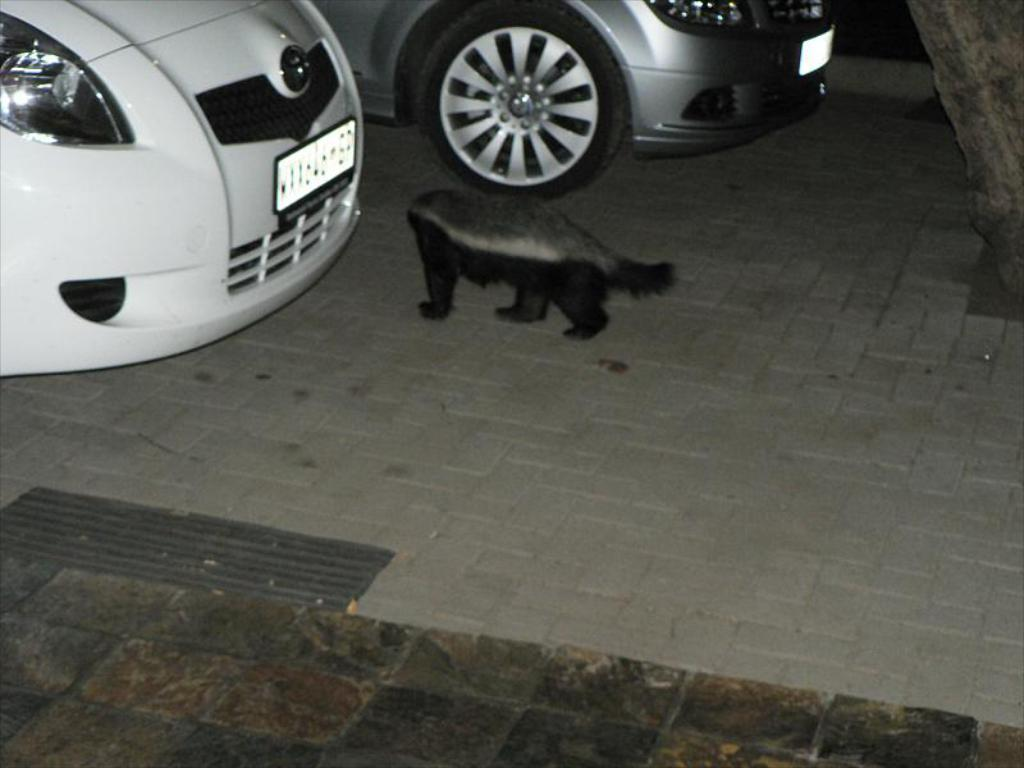What can be seen parked in the image? There are cars parked in the image. What else is present on the floor in the image? There is a dog puppy on the floor in the image. What is the color of the dog puppy? The dog puppy is black in color. What type of gate can be seen in the image? There is no gate present in the image; it only features cars parked and a dog puppy on the floor. 